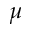Convert formula to latex. <formula><loc_0><loc_0><loc_500><loc_500>\mu</formula> 